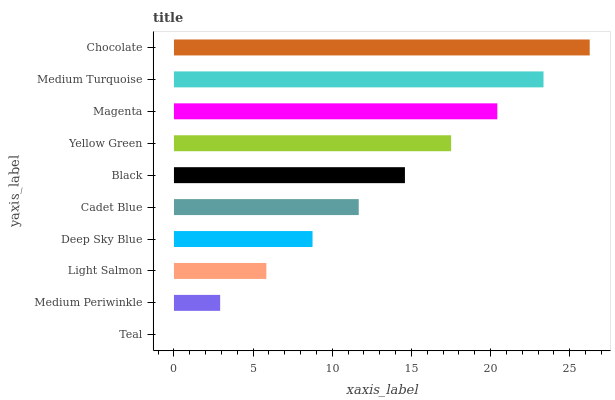Is Teal the minimum?
Answer yes or no. Yes. Is Chocolate the maximum?
Answer yes or no. Yes. Is Medium Periwinkle the minimum?
Answer yes or no. No. Is Medium Periwinkle the maximum?
Answer yes or no. No. Is Medium Periwinkle greater than Teal?
Answer yes or no. Yes. Is Teal less than Medium Periwinkle?
Answer yes or no. Yes. Is Teal greater than Medium Periwinkle?
Answer yes or no. No. Is Medium Periwinkle less than Teal?
Answer yes or no. No. Is Black the high median?
Answer yes or no. Yes. Is Cadet Blue the low median?
Answer yes or no. Yes. Is Medium Periwinkle the high median?
Answer yes or no. No. Is Light Salmon the low median?
Answer yes or no. No. 